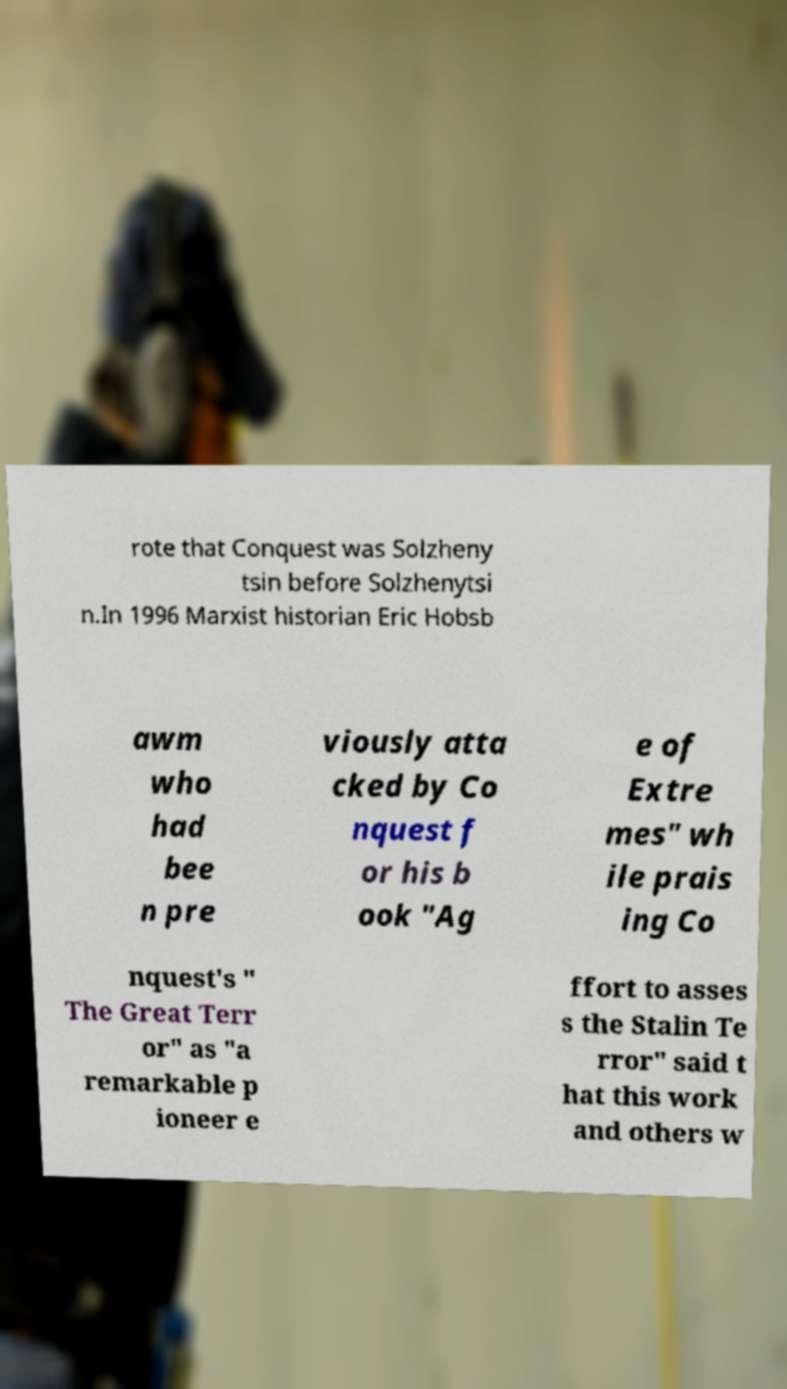Please identify and transcribe the text found in this image. rote that Conquest was Solzheny tsin before Solzhenytsi n.In 1996 Marxist historian Eric Hobsb awm who had bee n pre viously atta cked by Co nquest f or his b ook "Ag e of Extre mes" wh ile prais ing Co nquest's " The Great Terr or" as "a remarkable p ioneer e ffort to asses s the Stalin Te rror" said t hat this work and others w 